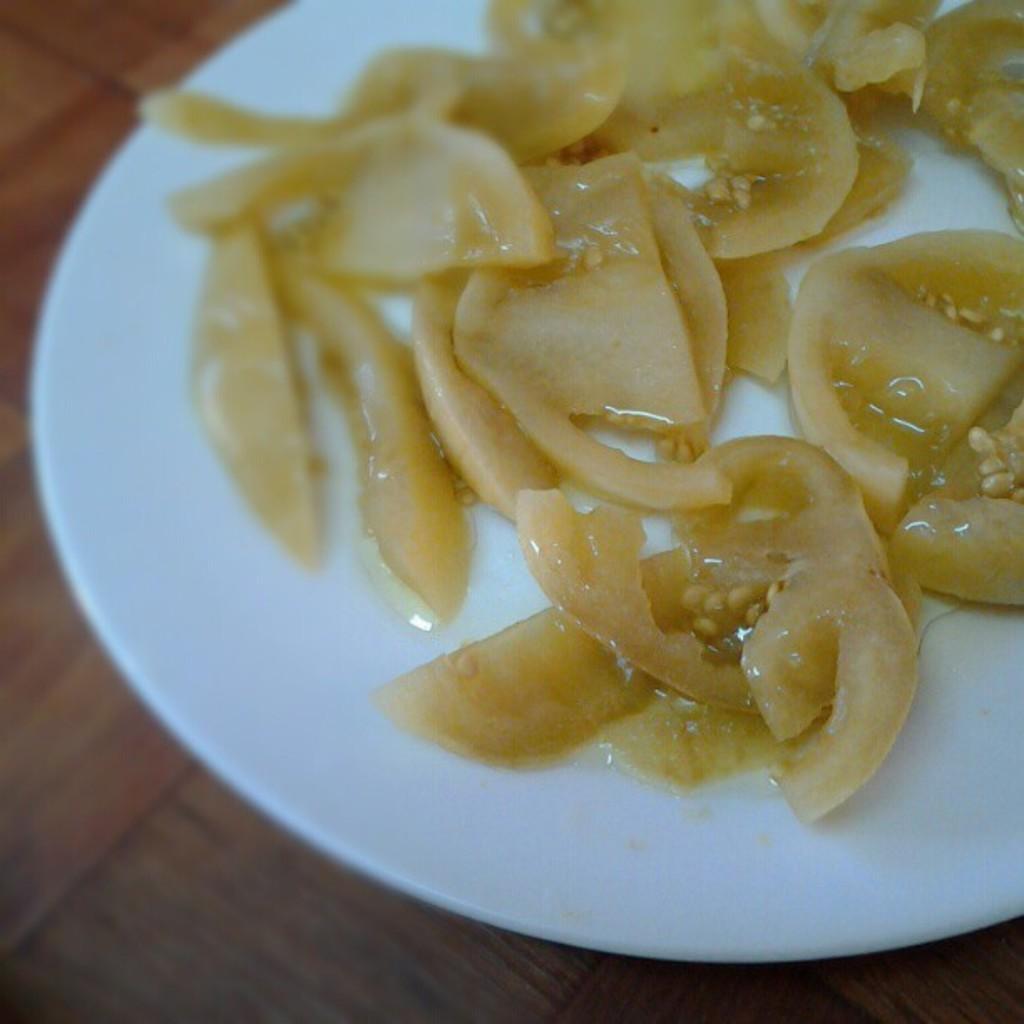How would you summarize this image in a sentence or two? In this image we can see food placed in a placed kept on the surface. 